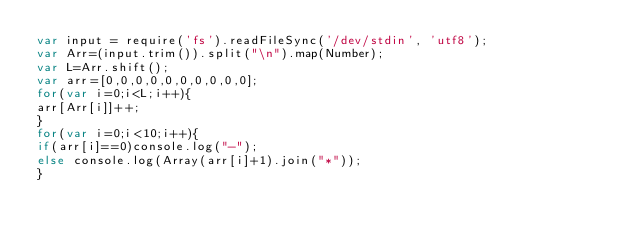Convert code to text. <code><loc_0><loc_0><loc_500><loc_500><_JavaScript_>var input = require('fs').readFileSync('/dev/stdin', 'utf8');
var Arr=(input.trim()).split("\n").map(Number);
var L=Arr.shift();
var arr=[0,0,0,0,0,0,0,0,0,0];
for(var i=0;i<L;i++){
arr[Arr[i]]++;
}
for(var i=0;i<10;i++){
if(arr[i]==0)console.log("-");
else console.log(Array(arr[i]+1).join("*"));
}</code> 